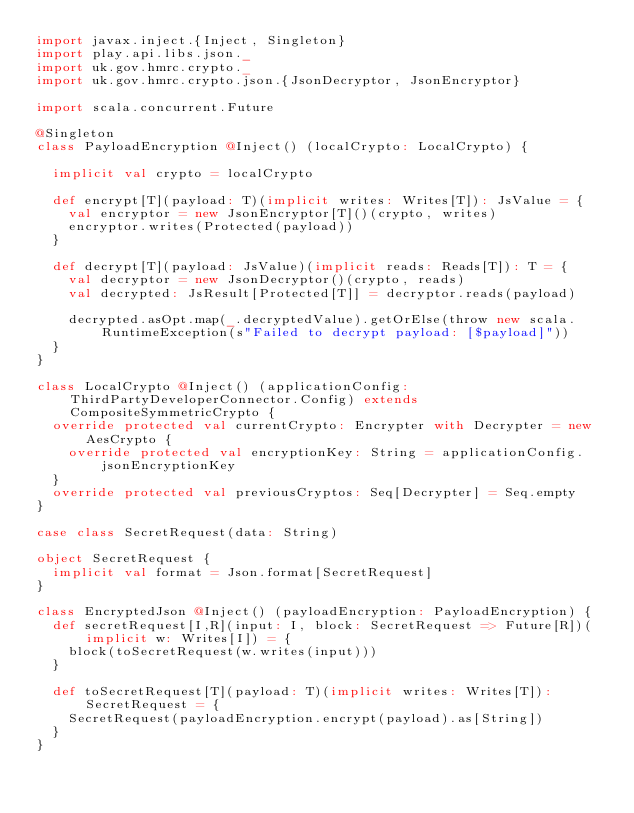Convert code to text. <code><loc_0><loc_0><loc_500><loc_500><_Scala_>import javax.inject.{Inject, Singleton}
import play.api.libs.json._
import uk.gov.hmrc.crypto._
import uk.gov.hmrc.crypto.json.{JsonDecryptor, JsonEncryptor}

import scala.concurrent.Future

@Singleton
class PayloadEncryption @Inject() (localCrypto: LocalCrypto) {

  implicit val crypto = localCrypto

  def encrypt[T](payload: T)(implicit writes: Writes[T]): JsValue = {
    val encryptor = new JsonEncryptor[T]()(crypto, writes)
    encryptor.writes(Protected(payload))
  }

  def decrypt[T](payload: JsValue)(implicit reads: Reads[T]): T = {
    val decryptor = new JsonDecryptor()(crypto, reads)
    val decrypted: JsResult[Protected[T]] = decryptor.reads(payload)

    decrypted.asOpt.map(_.decryptedValue).getOrElse(throw new scala.RuntimeException(s"Failed to decrypt payload: [$payload]"))
  }
}

class LocalCrypto @Inject() (applicationConfig: ThirdPartyDeveloperConnector.Config) extends CompositeSymmetricCrypto {
  override protected val currentCrypto: Encrypter with Decrypter = new AesCrypto {
    override protected val encryptionKey: String = applicationConfig.jsonEncryptionKey
  }
  override protected val previousCryptos: Seq[Decrypter] = Seq.empty
}

case class SecretRequest(data: String)

object SecretRequest {
  implicit val format = Json.format[SecretRequest]
}

class EncryptedJson @Inject() (payloadEncryption: PayloadEncryption) {
  def secretRequest[I,R](input: I, block: SecretRequest => Future[R])(implicit w: Writes[I]) = {
    block(toSecretRequest(w.writes(input)))
  }

  def toSecretRequest[T](payload: T)(implicit writes: Writes[T]): SecretRequest = {
    SecretRequest(payloadEncryption.encrypt(payload).as[String])
  }
}
</code> 